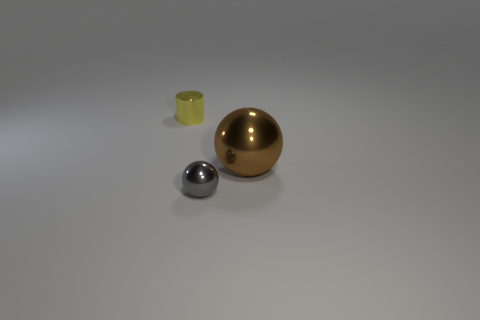There is a yellow metallic cylinder behind the tiny thing in front of the big metal object; what is its size?
Make the answer very short. Small. Are there any other things that have the same size as the brown metal sphere?
Offer a very short reply. No. Does the tiny thing right of the small cylinder have the same shape as the metallic thing behind the large shiny ball?
Provide a short and direct response. No. Is the number of tiny cylinders greater than the number of metal things?
Provide a succinct answer. No. What size is the brown metal sphere?
Provide a short and direct response. Large. How many other things are there of the same color as the big thing?
Your response must be concise. 0. Is the number of big spheres in front of the gray metallic sphere less than the number of balls that are right of the large brown ball?
Make the answer very short. No. How many other things are made of the same material as the cylinder?
Your answer should be compact. 2. Is the number of big metallic things behind the large brown ball less than the number of small gray things?
Provide a succinct answer. Yes. The small object in front of the ball behind the tiny metallic thing that is in front of the yellow object is what shape?
Keep it short and to the point. Sphere. 